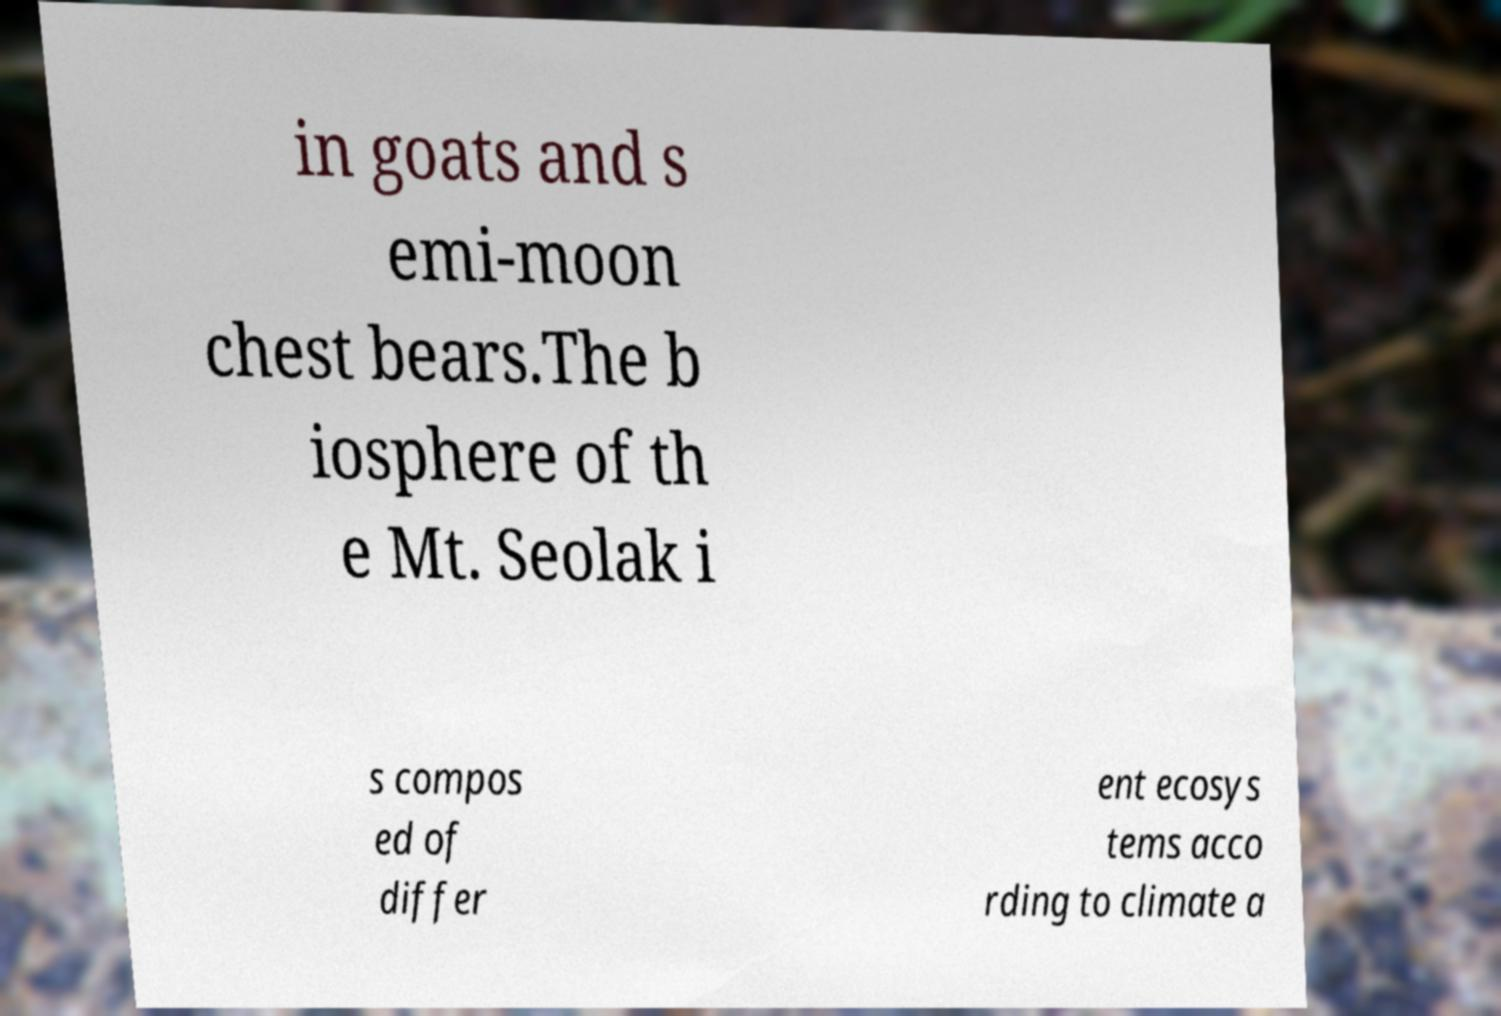What messages or text are displayed in this image? I need them in a readable, typed format. in goats and s emi-moon chest bears.The b iosphere of th e Mt. Seolak i s compos ed of differ ent ecosys tems acco rding to climate a 